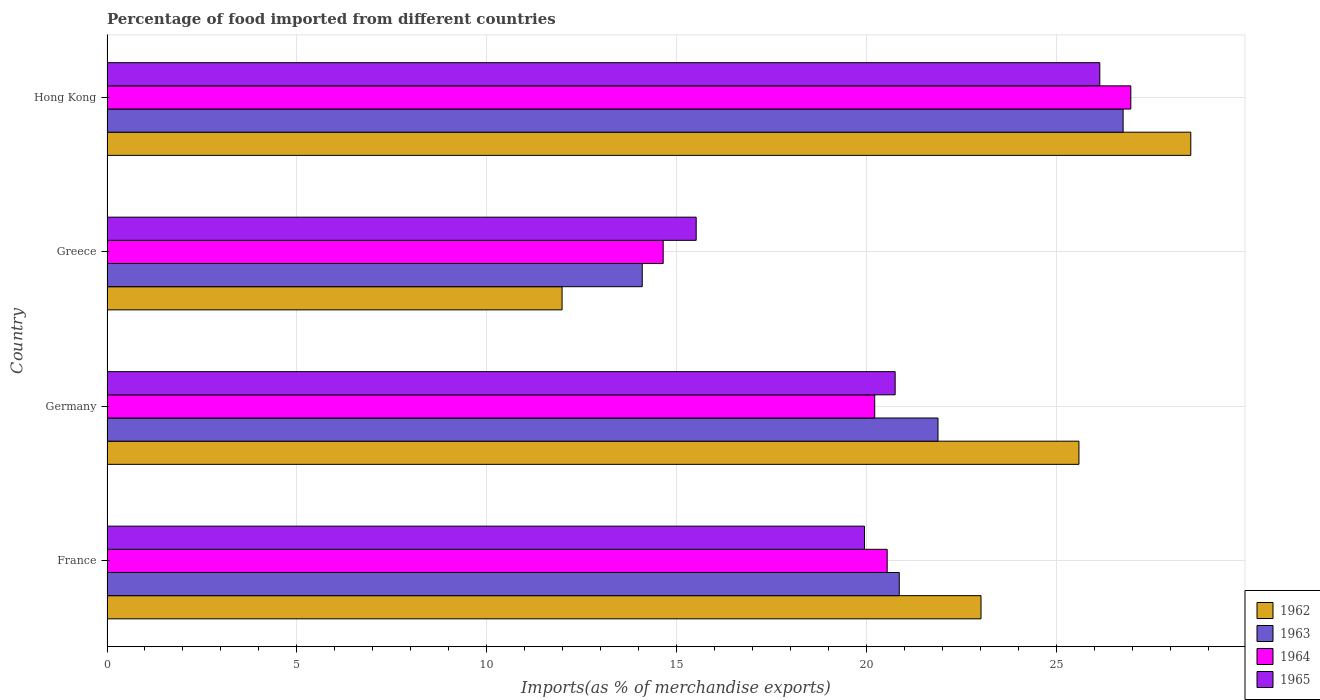How many different coloured bars are there?
Give a very brief answer. 4. How many groups of bars are there?
Offer a terse response. 4. Are the number of bars per tick equal to the number of legend labels?
Provide a succinct answer. Yes. Are the number of bars on each tick of the Y-axis equal?
Your answer should be compact. Yes. How many bars are there on the 1st tick from the top?
Your answer should be very brief. 4. How many bars are there on the 1st tick from the bottom?
Offer a terse response. 4. What is the label of the 2nd group of bars from the top?
Ensure brevity in your answer.  Greece. What is the percentage of imports to different countries in 1965 in Greece?
Your response must be concise. 15.51. Across all countries, what is the maximum percentage of imports to different countries in 1962?
Your answer should be compact. 28.53. Across all countries, what is the minimum percentage of imports to different countries in 1964?
Your response must be concise. 14.64. In which country was the percentage of imports to different countries in 1963 maximum?
Provide a short and direct response. Hong Kong. In which country was the percentage of imports to different countries in 1964 minimum?
Ensure brevity in your answer.  Greece. What is the total percentage of imports to different countries in 1965 in the graph?
Make the answer very short. 82.35. What is the difference between the percentage of imports to different countries in 1965 in France and that in Germany?
Your answer should be very brief. -0.81. What is the difference between the percentage of imports to different countries in 1963 in Greece and the percentage of imports to different countries in 1965 in Germany?
Make the answer very short. -6.66. What is the average percentage of imports to different countries in 1964 per country?
Ensure brevity in your answer.  20.59. What is the difference between the percentage of imports to different countries in 1965 and percentage of imports to different countries in 1962 in Greece?
Provide a short and direct response. 3.53. In how many countries, is the percentage of imports to different countries in 1963 greater than 12 %?
Keep it short and to the point. 4. What is the ratio of the percentage of imports to different countries in 1962 in France to that in Hong Kong?
Ensure brevity in your answer.  0.81. Is the percentage of imports to different countries in 1964 in France less than that in Germany?
Provide a short and direct response. No. Is the difference between the percentage of imports to different countries in 1965 in France and Hong Kong greater than the difference between the percentage of imports to different countries in 1962 in France and Hong Kong?
Make the answer very short. No. What is the difference between the highest and the second highest percentage of imports to different countries in 1964?
Your answer should be compact. 6.41. What is the difference between the highest and the lowest percentage of imports to different countries in 1964?
Offer a terse response. 12.31. In how many countries, is the percentage of imports to different countries in 1965 greater than the average percentage of imports to different countries in 1965 taken over all countries?
Offer a very short reply. 2. Is the sum of the percentage of imports to different countries in 1964 in France and Hong Kong greater than the maximum percentage of imports to different countries in 1963 across all countries?
Your answer should be very brief. Yes. Is it the case that in every country, the sum of the percentage of imports to different countries in 1965 and percentage of imports to different countries in 1962 is greater than the sum of percentage of imports to different countries in 1964 and percentage of imports to different countries in 1963?
Your answer should be very brief. No. What does the 2nd bar from the top in France represents?
Your answer should be very brief. 1964. What does the 3rd bar from the bottom in France represents?
Make the answer very short. 1964. Is it the case that in every country, the sum of the percentage of imports to different countries in 1962 and percentage of imports to different countries in 1963 is greater than the percentage of imports to different countries in 1965?
Give a very brief answer. Yes. Are all the bars in the graph horizontal?
Keep it short and to the point. Yes. Does the graph contain grids?
Provide a succinct answer. Yes. How many legend labels are there?
Give a very brief answer. 4. How are the legend labels stacked?
Make the answer very short. Vertical. What is the title of the graph?
Offer a terse response. Percentage of food imported from different countries. Does "2009" appear as one of the legend labels in the graph?
Offer a very short reply. No. What is the label or title of the X-axis?
Give a very brief answer. Imports(as % of merchandise exports). What is the Imports(as % of merchandise exports) of 1962 in France?
Give a very brief answer. 23.01. What is the Imports(as % of merchandise exports) in 1963 in France?
Keep it short and to the point. 20.86. What is the Imports(as % of merchandise exports) in 1964 in France?
Your response must be concise. 20.54. What is the Imports(as % of merchandise exports) in 1965 in France?
Your response must be concise. 19.94. What is the Imports(as % of merchandise exports) in 1962 in Germany?
Make the answer very short. 25.59. What is the Imports(as % of merchandise exports) in 1963 in Germany?
Make the answer very short. 21.88. What is the Imports(as % of merchandise exports) of 1964 in Germany?
Make the answer very short. 20.21. What is the Imports(as % of merchandise exports) in 1965 in Germany?
Offer a terse response. 20.75. What is the Imports(as % of merchandise exports) of 1962 in Greece?
Ensure brevity in your answer.  11.98. What is the Imports(as % of merchandise exports) in 1963 in Greece?
Your answer should be very brief. 14.09. What is the Imports(as % of merchandise exports) in 1964 in Greece?
Give a very brief answer. 14.64. What is the Imports(as % of merchandise exports) of 1965 in Greece?
Keep it short and to the point. 15.51. What is the Imports(as % of merchandise exports) of 1962 in Hong Kong?
Make the answer very short. 28.53. What is the Imports(as % of merchandise exports) in 1963 in Hong Kong?
Provide a succinct answer. 26.75. What is the Imports(as % of merchandise exports) in 1964 in Hong Kong?
Your answer should be very brief. 26.96. What is the Imports(as % of merchandise exports) of 1965 in Hong Kong?
Keep it short and to the point. 26.14. Across all countries, what is the maximum Imports(as % of merchandise exports) in 1962?
Your answer should be compact. 28.53. Across all countries, what is the maximum Imports(as % of merchandise exports) of 1963?
Your answer should be compact. 26.75. Across all countries, what is the maximum Imports(as % of merchandise exports) of 1964?
Provide a short and direct response. 26.96. Across all countries, what is the maximum Imports(as % of merchandise exports) in 1965?
Keep it short and to the point. 26.14. Across all countries, what is the minimum Imports(as % of merchandise exports) of 1962?
Offer a very short reply. 11.98. Across all countries, what is the minimum Imports(as % of merchandise exports) of 1963?
Keep it short and to the point. 14.09. Across all countries, what is the minimum Imports(as % of merchandise exports) of 1964?
Offer a terse response. 14.64. Across all countries, what is the minimum Imports(as % of merchandise exports) in 1965?
Your answer should be very brief. 15.51. What is the total Imports(as % of merchandise exports) in 1962 in the graph?
Your answer should be compact. 89.12. What is the total Imports(as % of merchandise exports) in 1963 in the graph?
Make the answer very short. 83.58. What is the total Imports(as % of merchandise exports) in 1964 in the graph?
Your answer should be very brief. 82.35. What is the total Imports(as % of merchandise exports) in 1965 in the graph?
Your answer should be compact. 82.35. What is the difference between the Imports(as % of merchandise exports) in 1962 in France and that in Germany?
Provide a succinct answer. -2.58. What is the difference between the Imports(as % of merchandise exports) of 1963 in France and that in Germany?
Ensure brevity in your answer.  -1.02. What is the difference between the Imports(as % of merchandise exports) in 1964 in France and that in Germany?
Offer a terse response. 0.33. What is the difference between the Imports(as % of merchandise exports) of 1965 in France and that in Germany?
Provide a short and direct response. -0.81. What is the difference between the Imports(as % of merchandise exports) in 1962 in France and that in Greece?
Ensure brevity in your answer.  11.03. What is the difference between the Imports(as % of merchandise exports) in 1963 in France and that in Greece?
Ensure brevity in your answer.  6.77. What is the difference between the Imports(as % of merchandise exports) in 1964 in France and that in Greece?
Your response must be concise. 5.9. What is the difference between the Imports(as % of merchandise exports) of 1965 in France and that in Greece?
Provide a short and direct response. 4.43. What is the difference between the Imports(as % of merchandise exports) of 1962 in France and that in Hong Kong?
Keep it short and to the point. -5.52. What is the difference between the Imports(as % of merchandise exports) in 1963 in France and that in Hong Kong?
Ensure brevity in your answer.  -5.89. What is the difference between the Imports(as % of merchandise exports) in 1964 in France and that in Hong Kong?
Make the answer very short. -6.41. What is the difference between the Imports(as % of merchandise exports) of 1965 in France and that in Hong Kong?
Provide a succinct answer. -6.2. What is the difference between the Imports(as % of merchandise exports) of 1962 in Germany and that in Greece?
Offer a terse response. 13.61. What is the difference between the Imports(as % of merchandise exports) of 1963 in Germany and that in Greece?
Give a very brief answer. 7.79. What is the difference between the Imports(as % of merchandise exports) of 1964 in Germany and that in Greece?
Keep it short and to the point. 5.57. What is the difference between the Imports(as % of merchandise exports) in 1965 in Germany and that in Greece?
Make the answer very short. 5.24. What is the difference between the Imports(as % of merchandise exports) in 1962 in Germany and that in Hong Kong?
Provide a short and direct response. -2.95. What is the difference between the Imports(as % of merchandise exports) in 1963 in Germany and that in Hong Kong?
Give a very brief answer. -4.87. What is the difference between the Imports(as % of merchandise exports) in 1964 in Germany and that in Hong Kong?
Make the answer very short. -6.74. What is the difference between the Imports(as % of merchandise exports) in 1965 in Germany and that in Hong Kong?
Make the answer very short. -5.39. What is the difference between the Imports(as % of merchandise exports) in 1962 in Greece and that in Hong Kong?
Offer a very short reply. -16.55. What is the difference between the Imports(as % of merchandise exports) in 1963 in Greece and that in Hong Kong?
Your response must be concise. -12.66. What is the difference between the Imports(as % of merchandise exports) in 1964 in Greece and that in Hong Kong?
Your answer should be compact. -12.31. What is the difference between the Imports(as % of merchandise exports) of 1965 in Greece and that in Hong Kong?
Keep it short and to the point. -10.63. What is the difference between the Imports(as % of merchandise exports) in 1962 in France and the Imports(as % of merchandise exports) in 1963 in Germany?
Your answer should be compact. 1.13. What is the difference between the Imports(as % of merchandise exports) in 1962 in France and the Imports(as % of merchandise exports) in 1964 in Germany?
Your response must be concise. 2.8. What is the difference between the Imports(as % of merchandise exports) in 1962 in France and the Imports(as % of merchandise exports) in 1965 in Germany?
Give a very brief answer. 2.26. What is the difference between the Imports(as % of merchandise exports) in 1963 in France and the Imports(as % of merchandise exports) in 1964 in Germany?
Provide a short and direct response. 0.65. What is the difference between the Imports(as % of merchandise exports) of 1963 in France and the Imports(as % of merchandise exports) of 1965 in Germany?
Make the answer very short. 0.11. What is the difference between the Imports(as % of merchandise exports) in 1964 in France and the Imports(as % of merchandise exports) in 1965 in Germany?
Offer a very short reply. -0.21. What is the difference between the Imports(as % of merchandise exports) in 1962 in France and the Imports(as % of merchandise exports) in 1963 in Greece?
Your answer should be compact. 8.92. What is the difference between the Imports(as % of merchandise exports) of 1962 in France and the Imports(as % of merchandise exports) of 1964 in Greece?
Your answer should be very brief. 8.37. What is the difference between the Imports(as % of merchandise exports) of 1962 in France and the Imports(as % of merchandise exports) of 1965 in Greece?
Provide a succinct answer. 7.5. What is the difference between the Imports(as % of merchandise exports) of 1963 in France and the Imports(as % of merchandise exports) of 1964 in Greece?
Offer a terse response. 6.22. What is the difference between the Imports(as % of merchandise exports) in 1963 in France and the Imports(as % of merchandise exports) in 1965 in Greece?
Offer a terse response. 5.35. What is the difference between the Imports(as % of merchandise exports) of 1964 in France and the Imports(as % of merchandise exports) of 1965 in Greece?
Offer a terse response. 5.03. What is the difference between the Imports(as % of merchandise exports) of 1962 in France and the Imports(as % of merchandise exports) of 1963 in Hong Kong?
Your answer should be compact. -3.74. What is the difference between the Imports(as % of merchandise exports) in 1962 in France and the Imports(as % of merchandise exports) in 1964 in Hong Kong?
Your answer should be very brief. -3.94. What is the difference between the Imports(as % of merchandise exports) of 1962 in France and the Imports(as % of merchandise exports) of 1965 in Hong Kong?
Provide a short and direct response. -3.13. What is the difference between the Imports(as % of merchandise exports) of 1963 in France and the Imports(as % of merchandise exports) of 1964 in Hong Kong?
Make the answer very short. -6.1. What is the difference between the Imports(as % of merchandise exports) of 1963 in France and the Imports(as % of merchandise exports) of 1965 in Hong Kong?
Your response must be concise. -5.28. What is the difference between the Imports(as % of merchandise exports) in 1964 in France and the Imports(as % of merchandise exports) in 1965 in Hong Kong?
Your response must be concise. -5.6. What is the difference between the Imports(as % of merchandise exports) in 1962 in Germany and the Imports(as % of merchandise exports) in 1963 in Greece?
Your answer should be very brief. 11.5. What is the difference between the Imports(as % of merchandise exports) in 1962 in Germany and the Imports(as % of merchandise exports) in 1964 in Greece?
Make the answer very short. 10.95. What is the difference between the Imports(as % of merchandise exports) of 1962 in Germany and the Imports(as % of merchandise exports) of 1965 in Greece?
Ensure brevity in your answer.  10.08. What is the difference between the Imports(as % of merchandise exports) in 1963 in Germany and the Imports(as % of merchandise exports) in 1964 in Greece?
Keep it short and to the point. 7.24. What is the difference between the Imports(as % of merchandise exports) of 1963 in Germany and the Imports(as % of merchandise exports) of 1965 in Greece?
Give a very brief answer. 6.37. What is the difference between the Imports(as % of merchandise exports) of 1964 in Germany and the Imports(as % of merchandise exports) of 1965 in Greece?
Offer a terse response. 4.7. What is the difference between the Imports(as % of merchandise exports) of 1962 in Germany and the Imports(as % of merchandise exports) of 1963 in Hong Kong?
Make the answer very short. -1.16. What is the difference between the Imports(as % of merchandise exports) of 1962 in Germany and the Imports(as % of merchandise exports) of 1964 in Hong Kong?
Your answer should be compact. -1.37. What is the difference between the Imports(as % of merchandise exports) in 1962 in Germany and the Imports(as % of merchandise exports) in 1965 in Hong Kong?
Provide a succinct answer. -0.55. What is the difference between the Imports(as % of merchandise exports) of 1963 in Germany and the Imports(as % of merchandise exports) of 1964 in Hong Kong?
Provide a succinct answer. -5.08. What is the difference between the Imports(as % of merchandise exports) of 1963 in Germany and the Imports(as % of merchandise exports) of 1965 in Hong Kong?
Provide a short and direct response. -4.26. What is the difference between the Imports(as % of merchandise exports) in 1964 in Germany and the Imports(as % of merchandise exports) in 1965 in Hong Kong?
Provide a short and direct response. -5.93. What is the difference between the Imports(as % of merchandise exports) of 1962 in Greece and the Imports(as % of merchandise exports) of 1963 in Hong Kong?
Your answer should be compact. -14.77. What is the difference between the Imports(as % of merchandise exports) of 1962 in Greece and the Imports(as % of merchandise exports) of 1964 in Hong Kong?
Your answer should be compact. -14.97. What is the difference between the Imports(as % of merchandise exports) of 1962 in Greece and the Imports(as % of merchandise exports) of 1965 in Hong Kong?
Your response must be concise. -14.16. What is the difference between the Imports(as % of merchandise exports) of 1963 in Greece and the Imports(as % of merchandise exports) of 1964 in Hong Kong?
Provide a succinct answer. -12.86. What is the difference between the Imports(as % of merchandise exports) in 1963 in Greece and the Imports(as % of merchandise exports) in 1965 in Hong Kong?
Your answer should be compact. -12.05. What is the difference between the Imports(as % of merchandise exports) in 1964 in Greece and the Imports(as % of merchandise exports) in 1965 in Hong Kong?
Your response must be concise. -11.5. What is the average Imports(as % of merchandise exports) of 1962 per country?
Ensure brevity in your answer.  22.28. What is the average Imports(as % of merchandise exports) of 1963 per country?
Provide a succinct answer. 20.9. What is the average Imports(as % of merchandise exports) in 1964 per country?
Provide a succinct answer. 20.59. What is the average Imports(as % of merchandise exports) of 1965 per country?
Your answer should be very brief. 20.59. What is the difference between the Imports(as % of merchandise exports) of 1962 and Imports(as % of merchandise exports) of 1963 in France?
Provide a short and direct response. 2.15. What is the difference between the Imports(as % of merchandise exports) in 1962 and Imports(as % of merchandise exports) in 1964 in France?
Your answer should be very brief. 2.47. What is the difference between the Imports(as % of merchandise exports) of 1962 and Imports(as % of merchandise exports) of 1965 in France?
Your answer should be compact. 3.07. What is the difference between the Imports(as % of merchandise exports) in 1963 and Imports(as % of merchandise exports) in 1964 in France?
Make the answer very short. 0.32. What is the difference between the Imports(as % of merchandise exports) in 1963 and Imports(as % of merchandise exports) in 1965 in France?
Your answer should be very brief. 0.92. What is the difference between the Imports(as % of merchandise exports) of 1964 and Imports(as % of merchandise exports) of 1965 in France?
Your response must be concise. 0.6. What is the difference between the Imports(as % of merchandise exports) of 1962 and Imports(as % of merchandise exports) of 1963 in Germany?
Ensure brevity in your answer.  3.71. What is the difference between the Imports(as % of merchandise exports) in 1962 and Imports(as % of merchandise exports) in 1964 in Germany?
Your response must be concise. 5.38. What is the difference between the Imports(as % of merchandise exports) in 1962 and Imports(as % of merchandise exports) in 1965 in Germany?
Offer a very short reply. 4.84. What is the difference between the Imports(as % of merchandise exports) in 1963 and Imports(as % of merchandise exports) in 1964 in Germany?
Provide a short and direct response. 1.67. What is the difference between the Imports(as % of merchandise exports) in 1963 and Imports(as % of merchandise exports) in 1965 in Germany?
Offer a terse response. 1.13. What is the difference between the Imports(as % of merchandise exports) of 1964 and Imports(as % of merchandise exports) of 1965 in Germany?
Provide a short and direct response. -0.54. What is the difference between the Imports(as % of merchandise exports) of 1962 and Imports(as % of merchandise exports) of 1963 in Greece?
Keep it short and to the point. -2.11. What is the difference between the Imports(as % of merchandise exports) of 1962 and Imports(as % of merchandise exports) of 1964 in Greece?
Give a very brief answer. -2.66. What is the difference between the Imports(as % of merchandise exports) of 1962 and Imports(as % of merchandise exports) of 1965 in Greece?
Ensure brevity in your answer.  -3.53. What is the difference between the Imports(as % of merchandise exports) in 1963 and Imports(as % of merchandise exports) in 1964 in Greece?
Your answer should be compact. -0.55. What is the difference between the Imports(as % of merchandise exports) of 1963 and Imports(as % of merchandise exports) of 1965 in Greece?
Offer a terse response. -1.42. What is the difference between the Imports(as % of merchandise exports) in 1964 and Imports(as % of merchandise exports) in 1965 in Greece?
Offer a terse response. -0.87. What is the difference between the Imports(as % of merchandise exports) in 1962 and Imports(as % of merchandise exports) in 1963 in Hong Kong?
Make the answer very short. 1.78. What is the difference between the Imports(as % of merchandise exports) of 1962 and Imports(as % of merchandise exports) of 1964 in Hong Kong?
Provide a short and direct response. 1.58. What is the difference between the Imports(as % of merchandise exports) of 1962 and Imports(as % of merchandise exports) of 1965 in Hong Kong?
Your answer should be very brief. 2.4. What is the difference between the Imports(as % of merchandise exports) of 1963 and Imports(as % of merchandise exports) of 1964 in Hong Kong?
Ensure brevity in your answer.  -0.2. What is the difference between the Imports(as % of merchandise exports) of 1963 and Imports(as % of merchandise exports) of 1965 in Hong Kong?
Make the answer very short. 0.61. What is the difference between the Imports(as % of merchandise exports) in 1964 and Imports(as % of merchandise exports) in 1965 in Hong Kong?
Make the answer very short. 0.82. What is the ratio of the Imports(as % of merchandise exports) in 1962 in France to that in Germany?
Keep it short and to the point. 0.9. What is the ratio of the Imports(as % of merchandise exports) of 1963 in France to that in Germany?
Give a very brief answer. 0.95. What is the ratio of the Imports(as % of merchandise exports) in 1964 in France to that in Germany?
Your answer should be compact. 1.02. What is the ratio of the Imports(as % of merchandise exports) in 1965 in France to that in Germany?
Provide a succinct answer. 0.96. What is the ratio of the Imports(as % of merchandise exports) of 1962 in France to that in Greece?
Keep it short and to the point. 1.92. What is the ratio of the Imports(as % of merchandise exports) of 1963 in France to that in Greece?
Keep it short and to the point. 1.48. What is the ratio of the Imports(as % of merchandise exports) in 1964 in France to that in Greece?
Your response must be concise. 1.4. What is the ratio of the Imports(as % of merchandise exports) of 1965 in France to that in Greece?
Your response must be concise. 1.29. What is the ratio of the Imports(as % of merchandise exports) in 1962 in France to that in Hong Kong?
Ensure brevity in your answer.  0.81. What is the ratio of the Imports(as % of merchandise exports) in 1963 in France to that in Hong Kong?
Ensure brevity in your answer.  0.78. What is the ratio of the Imports(as % of merchandise exports) in 1964 in France to that in Hong Kong?
Ensure brevity in your answer.  0.76. What is the ratio of the Imports(as % of merchandise exports) of 1965 in France to that in Hong Kong?
Make the answer very short. 0.76. What is the ratio of the Imports(as % of merchandise exports) in 1962 in Germany to that in Greece?
Make the answer very short. 2.14. What is the ratio of the Imports(as % of merchandise exports) of 1963 in Germany to that in Greece?
Offer a very short reply. 1.55. What is the ratio of the Imports(as % of merchandise exports) in 1964 in Germany to that in Greece?
Keep it short and to the point. 1.38. What is the ratio of the Imports(as % of merchandise exports) in 1965 in Germany to that in Greece?
Offer a terse response. 1.34. What is the ratio of the Imports(as % of merchandise exports) of 1962 in Germany to that in Hong Kong?
Offer a terse response. 0.9. What is the ratio of the Imports(as % of merchandise exports) of 1963 in Germany to that in Hong Kong?
Provide a short and direct response. 0.82. What is the ratio of the Imports(as % of merchandise exports) in 1964 in Germany to that in Hong Kong?
Give a very brief answer. 0.75. What is the ratio of the Imports(as % of merchandise exports) of 1965 in Germany to that in Hong Kong?
Give a very brief answer. 0.79. What is the ratio of the Imports(as % of merchandise exports) of 1962 in Greece to that in Hong Kong?
Keep it short and to the point. 0.42. What is the ratio of the Imports(as % of merchandise exports) of 1963 in Greece to that in Hong Kong?
Provide a short and direct response. 0.53. What is the ratio of the Imports(as % of merchandise exports) in 1964 in Greece to that in Hong Kong?
Your answer should be very brief. 0.54. What is the ratio of the Imports(as % of merchandise exports) of 1965 in Greece to that in Hong Kong?
Offer a very short reply. 0.59. What is the difference between the highest and the second highest Imports(as % of merchandise exports) of 1962?
Your answer should be very brief. 2.95. What is the difference between the highest and the second highest Imports(as % of merchandise exports) of 1963?
Provide a succinct answer. 4.87. What is the difference between the highest and the second highest Imports(as % of merchandise exports) in 1964?
Your answer should be compact. 6.41. What is the difference between the highest and the second highest Imports(as % of merchandise exports) of 1965?
Give a very brief answer. 5.39. What is the difference between the highest and the lowest Imports(as % of merchandise exports) in 1962?
Offer a very short reply. 16.55. What is the difference between the highest and the lowest Imports(as % of merchandise exports) in 1963?
Your answer should be very brief. 12.66. What is the difference between the highest and the lowest Imports(as % of merchandise exports) of 1964?
Your response must be concise. 12.31. What is the difference between the highest and the lowest Imports(as % of merchandise exports) in 1965?
Offer a very short reply. 10.63. 